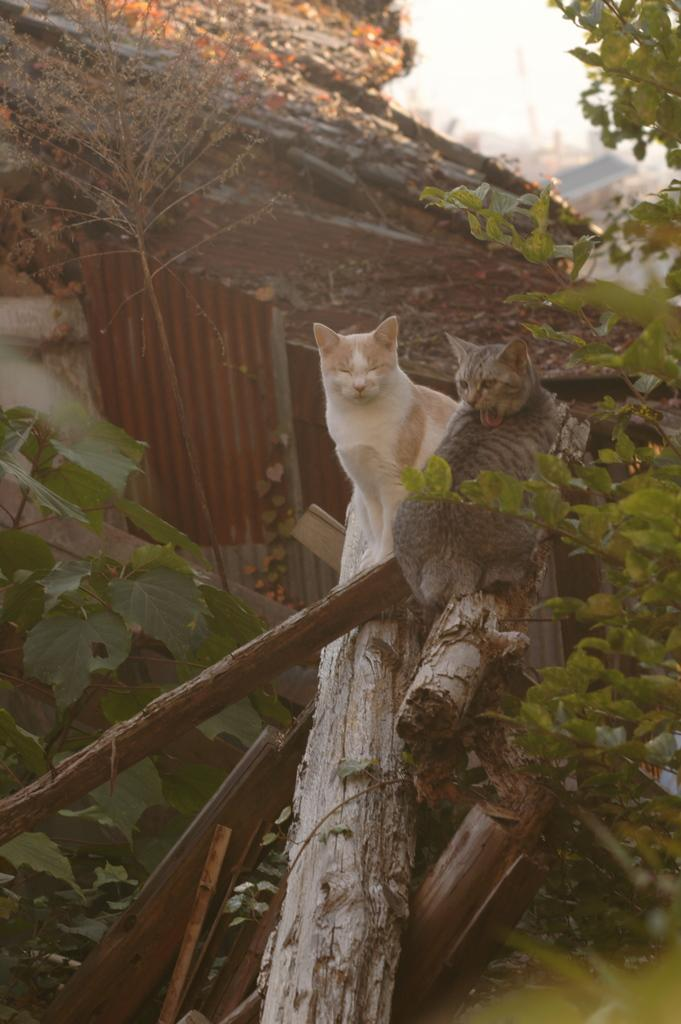How many cats can be seen in the image? There are two cats in the image. What type of material are the logs made of in the image? The logs in the image are made of wood. What other living organisms are present in the image? There are plants in the image. What can be seen in the background of the image? There are objects and the sky visible in the background of the image. What type of prose is being written by the kitty in the image? There is no kitty present in the image, and no prose is being written. 